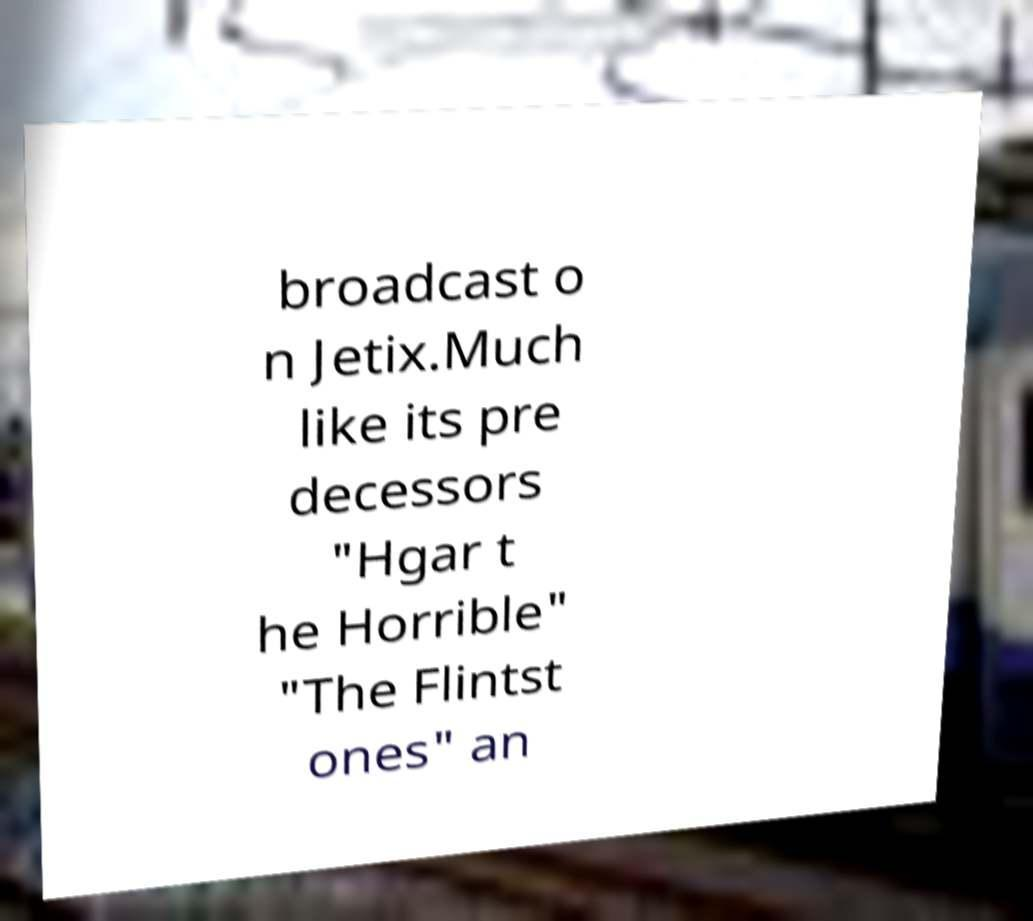For documentation purposes, I need the text within this image transcribed. Could you provide that? broadcast o n Jetix.Much like its pre decessors "Hgar t he Horrible" "The Flintst ones" an 